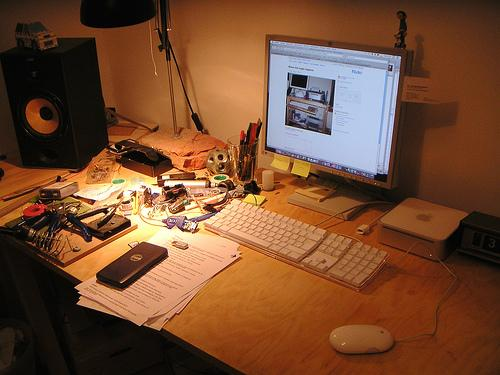Provide a description of the image's predominant sentiment or atmosphere. The image portrays a cluttered and busy workspace, possibly invoking a sense of disorganization or chaos. Count how many instances of speakers are captured in the photograph. There are two instances of black speakers in the photograph. What device allowing users to input text can be found on the image? A white and silver keyboard can be found on the image for users to input text. Identify the most prominent source of lighting in this picture. An adjustable desk lamp is the most prominent source of lighting in this picture. Discuss any object interactions or possible relationships among the objects observed within the image. There is a possible relationship between the white and silver keyboard, the white apple computer mouse, and the computer monitors, as they are all computer peripherals. Additionally, the messy stack of papers and the phone on top of it might indicate a busy work setting. Please enumerate the variety of computer-related items present within this image. The image includes a desktop computer monitor, an apple mini computer, a white apple computer mouse, a backlit computer screen, a white computer keyboard, and an oval white computer mouse. Which items in the image can store or display digital information? A desktop computer monitor, a backlit computer screen, a desktop computer, an apple mini computer, and a computer monitor can store or display digital information. Can you find the green potted plant in the top corner? It needs to be watered. No, there is no green potted plant visible in the image. 